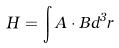<formula> <loc_0><loc_0><loc_500><loc_500>H = \int A \cdot B d ^ { 3 } r</formula> 